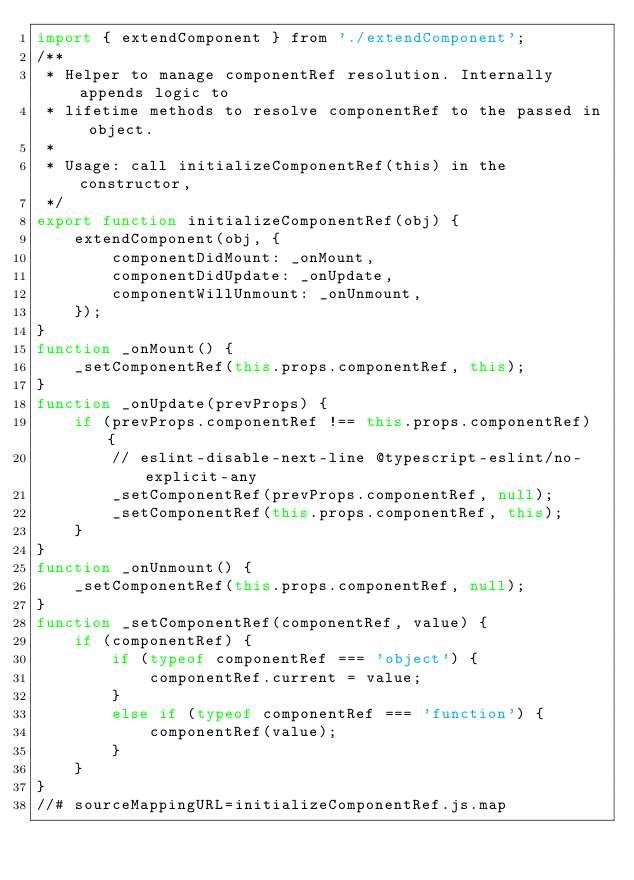Convert code to text. <code><loc_0><loc_0><loc_500><loc_500><_JavaScript_>import { extendComponent } from './extendComponent';
/**
 * Helper to manage componentRef resolution. Internally appends logic to
 * lifetime methods to resolve componentRef to the passed in object.
 *
 * Usage: call initializeComponentRef(this) in the constructor,
 */
export function initializeComponentRef(obj) {
    extendComponent(obj, {
        componentDidMount: _onMount,
        componentDidUpdate: _onUpdate,
        componentWillUnmount: _onUnmount,
    });
}
function _onMount() {
    _setComponentRef(this.props.componentRef, this);
}
function _onUpdate(prevProps) {
    if (prevProps.componentRef !== this.props.componentRef) {
        // eslint-disable-next-line @typescript-eslint/no-explicit-any
        _setComponentRef(prevProps.componentRef, null);
        _setComponentRef(this.props.componentRef, this);
    }
}
function _onUnmount() {
    _setComponentRef(this.props.componentRef, null);
}
function _setComponentRef(componentRef, value) {
    if (componentRef) {
        if (typeof componentRef === 'object') {
            componentRef.current = value;
        }
        else if (typeof componentRef === 'function') {
            componentRef(value);
        }
    }
}
//# sourceMappingURL=initializeComponentRef.js.map</code> 